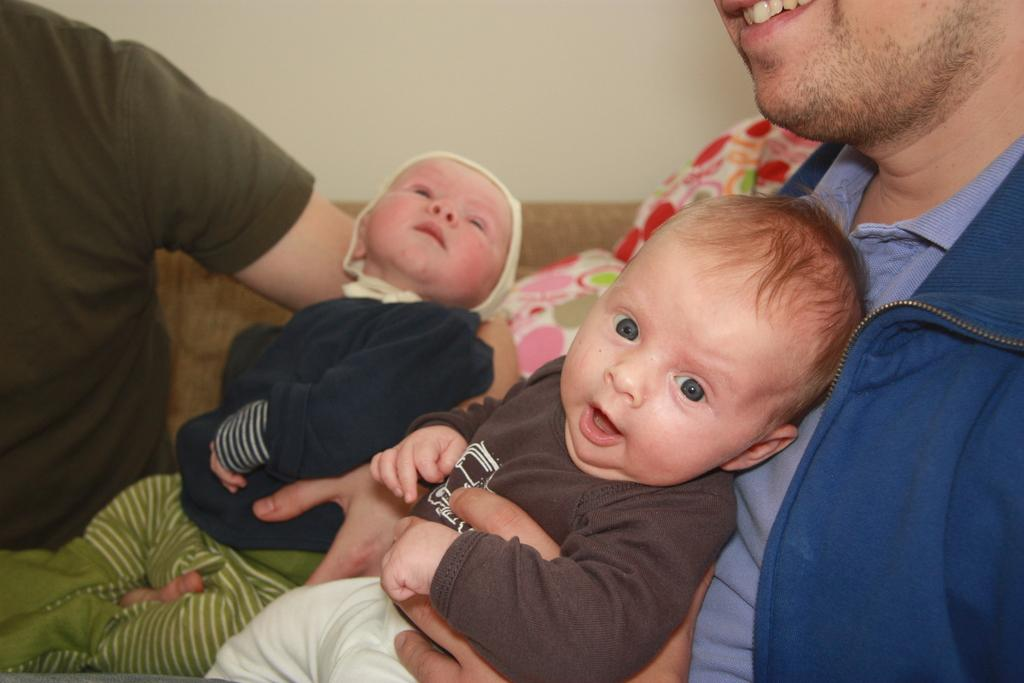What are the persons in the image doing? The persons in the image are holding babies. What can be seen in the background of the image? There is a wall and a sofa in the background of the image. What type of rod is being used to hold the babies in the image? There is no rod present in the image; the persons are holding the babies with their arms. How many grapes are visible in the image? There are no grapes present in the image. 